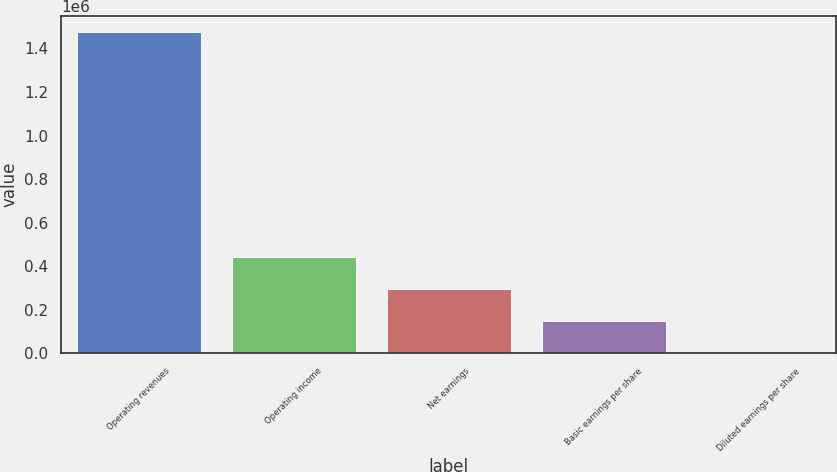Convert chart. <chart><loc_0><loc_0><loc_500><loc_500><bar_chart><fcel>Operating revenues<fcel>Operating income<fcel>Net earnings<fcel>Basic earnings per share<fcel>Diluted earnings per share<nl><fcel>1.47428e+06<fcel>442283<fcel>294856<fcel>147428<fcel>0.77<nl></chart> 